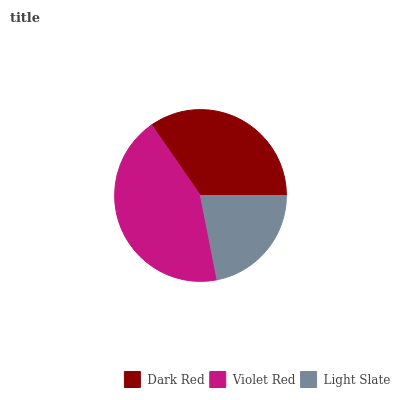Is Light Slate the minimum?
Answer yes or no. Yes. Is Violet Red the maximum?
Answer yes or no. Yes. Is Violet Red the minimum?
Answer yes or no. No. Is Light Slate the maximum?
Answer yes or no. No. Is Violet Red greater than Light Slate?
Answer yes or no. Yes. Is Light Slate less than Violet Red?
Answer yes or no. Yes. Is Light Slate greater than Violet Red?
Answer yes or no. No. Is Violet Red less than Light Slate?
Answer yes or no. No. Is Dark Red the high median?
Answer yes or no. Yes. Is Dark Red the low median?
Answer yes or no. Yes. Is Light Slate the high median?
Answer yes or no. No. Is Light Slate the low median?
Answer yes or no. No. 